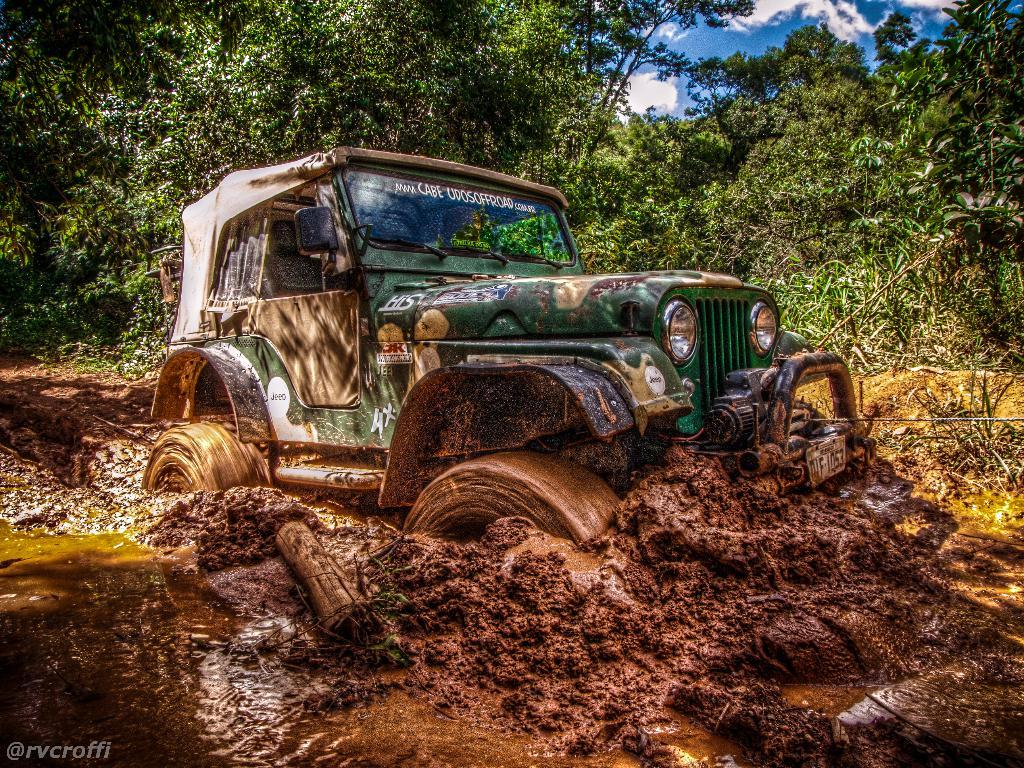What is the main subject of the image? The main subject of the image is a vehicle in the mud. What can be seen in the foreground of the image? There is text in the foreground area of the image. What type of natural environment is visible in the background of the image? There are trees in the background of the image. What else can be seen in the background of the image? The sky is visible in the background of the image. What type of cow can be seen wearing a badge in the image? There is no cow or badge present in the image; it features a vehicle in the mud with text in the foreground and trees and sky in the background. 